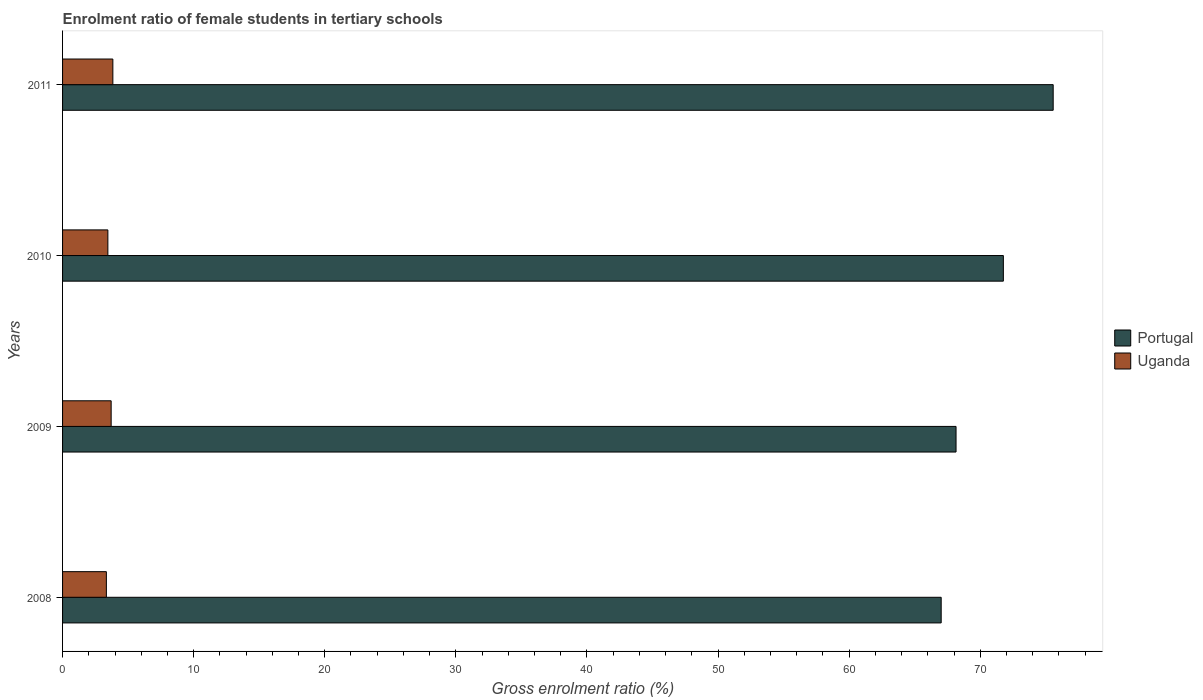How many different coloured bars are there?
Provide a succinct answer. 2. How many groups of bars are there?
Provide a short and direct response. 4. Are the number of bars per tick equal to the number of legend labels?
Give a very brief answer. Yes. In how many cases, is the number of bars for a given year not equal to the number of legend labels?
Give a very brief answer. 0. What is the enrolment ratio of female students in tertiary schools in Uganda in 2011?
Your answer should be very brief. 3.84. Across all years, what is the maximum enrolment ratio of female students in tertiary schools in Portugal?
Ensure brevity in your answer.  75.56. Across all years, what is the minimum enrolment ratio of female students in tertiary schools in Portugal?
Keep it short and to the point. 67.02. In which year was the enrolment ratio of female students in tertiary schools in Portugal minimum?
Make the answer very short. 2008. What is the total enrolment ratio of female students in tertiary schools in Uganda in the graph?
Your response must be concise. 14.34. What is the difference between the enrolment ratio of female students in tertiary schools in Portugal in 2008 and that in 2009?
Your response must be concise. -1.13. What is the difference between the enrolment ratio of female students in tertiary schools in Portugal in 2010 and the enrolment ratio of female students in tertiary schools in Uganda in 2011?
Make the answer very short. 67.92. What is the average enrolment ratio of female students in tertiary schools in Portugal per year?
Your response must be concise. 70.62. In the year 2009, what is the difference between the enrolment ratio of female students in tertiary schools in Portugal and enrolment ratio of female students in tertiary schools in Uganda?
Provide a short and direct response. 64.44. In how many years, is the enrolment ratio of female students in tertiary schools in Portugal greater than 8 %?
Provide a short and direct response. 4. What is the ratio of the enrolment ratio of female students in tertiary schools in Uganda in 2010 to that in 2011?
Make the answer very short. 0.9. Is the enrolment ratio of female students in tertiary schools in Uganda in 2008 less than that in 2011?
Offer a terse response. Yes. Is the difference between the enrolment ratio of female students in tertiary schools in Portugal in 2008 and 2009 greater than the difference between the enrolment ratio of female students in tertiary schools in Uganda in 2008 and 2009?
Ensure brevity in your answer.  No. What is the difference between the highest and the second highest enrolment ratio of female students in tertiary schools in Uganda?
Give a very brief answer. 0.13. What is the difference between the highest and the lowest enrolment ratio of female students in tertiary schools in Uganda?
Provide a succinct answer. 0.5. In how many years, is the enrolment ratio of female students in tertiary schools in Portugal greater than the average enrolment ratio of female students in tertiary schools in Portugal taken over all years?
Make the answer very short. 2. Is the sum of the enrolment ratio of female students in tertiary schools in Uganda in 2009 and 2011 greater than the maximum enrolment ratio of female students in tertiary schools in Portugal across all years?
Your response must be concise. No. What does the 1st bar from the top in 2011 represents?
Make the answer very short. Uganda. What does the 2nd bar from the bottom in 2010 represents?
Offer a terse response. Uganda. How many bars are there?
Provide a short and direct response. 8. How many years are there in the graph?
Keep it short and to the point. 4. What is the difference between two consecutive major ticks on the X-axis?
Offer a terse response. 10. Are the values on the major ticks of X-axis written in scientific E-notation?
Provide a succinct answer. No. Does the graph contain any zero values?
Your response must be concise. No. Does the graph contain grids?
Your response must be concise. No. What is the title of the graph?
Provide a short and direct response. Enrolment ratio of female students in tertiary schools. Does "Greenland" appear as one of the legend labels in the graph?
Provide a succinct answer. No. What is the Gross enrolment ratio (%) of Portugal in 2008?
Provide a succinct answer. 67.02. What is the Gross enrolment ratio (%) of Uganda in 2008?
Your response must be concise. 3.34. What is the Gross enrolment ratio (%) of Portugal in 2009?
Offer a terse response. 68.15. What is the Gross enrolment ratio (%) in Uganda in 2009?
Offer a very short reply. 3.71. What is the Gross enrolment ratio (%) of Portugal in 2010?
Make the answer very short. 71.76. What is the Gross enrolment ratio (%) in Uganda in 2010?
Ensure brevity in your answer.  3.46. What is the Gross enrolment ratio (%) in Portugal in 2011?
Offer a terse response. 75.56. What is the Gross enrolment ratio (%) in Uganda in 2011?
Provide a succinct answer. 3.84. Across all years, what is the maximum Gross enrolment ratio (%) in Portugal?
Provide a short and direct response. 75.56. Across all years, what is the maximum Gross enrolment ratio (%) in Uganda?
Keep it short and to the point. 3.84. Across all years, what is the minimum Gross enrolment ratio (%) in Portugal?
Ensure brevity in your answer.  67.02. Across all years, what is the minimum Gross enrolment ratio (%) in Uganda?
Your answer should be compact. 3.34. What is the total Gross enrolment ratio (%) in Portugal in the graph?
Your answer should be very brief. 282.49. What is the total Gross enrolment ratio (%) of Uganda in the graph?
Keep it short and to the point. 14.34. What is the difference between the Gross enrolment ratio (%) in Portugal in 2008 and that in 2009?
Give a very brief answer. -1.13. What is the difference between the Gross enrolment ratio (%) in Uganda in 2008 and that in 2009?
Your response must be concise. -0.37. What is the difference between the Gross enrolment ratio (%) of Portugal in 2008 and that in 2010?
Your answer should be very brief. -4.74. What is the difference between the Gross enrolment ratio (%) of Uganda in 2008 and that in 2010?
Offer a terse response. -0.11. What is the difference between the Gross enrolment ratio (%) in Portugal in 2008 and that in 2011?
Your response must be concise. -8.54. What is the difference between the Gross enrolment ratio (%) in Uganda in 2008 and that in 2011?
Your response must be concise. -0.5. What is the difference between the Gross enrolment ratio (%) in Portugal in 2009 and that in 2010?
Keep it short and to the point. -3.61. What is the difference between the Gross enrolment ratio (%) of Uganda in 2009 and that in 2010?
Provide a short and direct response. 0.25. What is the difference between the Gross enrolment ratio (%) in Portugal in 2009 and that in 2011?
Give a very brief answer. -7.41. What is the difference between the Gross enrolment ratio (%) in Uganda in 2009 and that in 2011?
Your response must be concise. -0.13. What is the difference between the Gross enrolment ratio (%) of Portugal in 2010 and that in 2011?
Make the answer very short. -3.8. What is the difference between the Gross enrolment ratio (%) of Uganda in 2010 and that in 2011?
Provide a succinct answer. -0.38. What is the difference between the Gross enrolment ratio (%) of Portugal in 2008 and the Gross enrolment ratio (%) of Uganda in 2009?
Your answer should be compact. 63.31. What is the difference between the Gross enrolment ratio (%) of Portugal in 2008 and the Gross enrolment ratio (%) of Uganda in 2010?
Offer a very short reply. 63.56. What is the difference between the Gross enrolment ratio (%) of Portugal in 2008 and the Gross enrolment ratio (%) of Uganda in 2011?
Your response must be concise. 63.18. What is the difference between the Gross enrolment ratio (%) of Portugal in 2009 and the Gross enrolment ratio (%) of Uganda in 2010?
Make the answer very short. 64.69. What is the difference between the Gross enrolment ratio (%) in Portugal in 2009 and the Gross enrolment ratio (%) in Uganda in 2011?
Your response must be concise. 64.31. What is the difference between the Gross enrolment ratio (%) in Portugal in 2010 and the Gross enrolment ratio (%) in Uganda in 2011?
Your response must be concise. 67.92. What is the average Gross enrolment ratio (%) of Portugal per year?
Make the answer very short. 70.62. What is the average Gross enrolment ratio (%) in Uganda per year?
Your response must be concise. 3.59. In the year 2008, what is the difference between the Gross enrolment ratio (%) in Portugal and Gross enrolment ratio (%) in Uganda?
Your answer should be compact. 63.68. In the year 2009, what is the difference between the Gross enrolment ratio (%) of Portugal and Gross enrolment ratio (%) of Uganda?
Offer a very short reply. 64.44. In the year 2010, what is the difference between the Gross enrolment ratio (%) of Portugal and Gross enrolment ratio (%) of Uganda?
Ensure brevity in your answer.  68.3. In the year 2011, what is the difference between the Gross enrolment ratio (%) of Portugal and Gross enrolment ratio (%) of Uganda?
Provide a short and direct response. 71.72. What is the ratio of the Gross enrolment ratio (%) in Portugal in 2008 to that in 2009?
Offer a very short reply. 0.98. What is the ratio of the Gross enrolment ratio (%) in Uganda in 2008 to that in 2009?
Keep it short and to the point. 0.9. What is the ratio of the Gross enrolment ratio (%) in Portugal in 2008 to that in 2010?
Make the answer very short. 0.93. What is the ratio of the Gross enrolment ratio (%) of Uganda in 2008 to that in 2010?
Make the answer very short. 0.97. What is the ratio of the Gross enrolment ratio (%) of Portugal in 2008 to that in 2011?
Provide a short and direct response. 0.89. What is the ratio of the Gross enrolment ratio (%) of Uganda in 2008 to that in 2011?
Offer a terse response. 0.87. What is the ratio of the Gross enrolment ratio (%) of Portugal in 2009 to that in 2010?
Your answer should be very brief. 0.95. What is the ratio of the Gross enrolment ratio (%) in Uganda in 2009 to that in 2010?
Offer a very short reply. 1.07. What is the ratio of the Gross enrolment ratio (%) in Portugal in 2009 to that in 2011?
Give a very brief answer. 0.9. What is the ratio of the Gross enrolment ratio (%) in Uganda in 2009 to that in 2011?
Your answer should be compact. 0.97. What is the ratio of the Gross enrolment ratio (%) in Portugal in 2010 to that in 2011?
Keep it short and to the point. 0.95. What is the ratio of the Gross enrolment ratio (%) in Uganda in 2010 to that in 2011?
Provide a short and direct response. 0.9. What is the difference between the highest and the second highest Gross enrolment ratio (%) of Portugal?
Give a very brief answer. 3.8. What is the difference between the highest and the second highest Gross enrolment ratio (%) of Uganda?
Ensure brevity in your answer.  0.13. What is the difference between the highest and the lowest Gross enrolment ratio (%) of Portugal?
Your response must be concise. 8.54. What is the difference between the highest and the lowest Gross enrolment ratio (%) in Uganda?
Your answer should be compact. 0.5. 